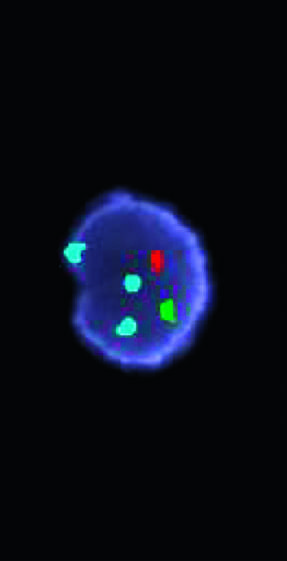does the glomerulus hybridize to the x chromosome centromere?
Answer the question using a single word or phrase. No 